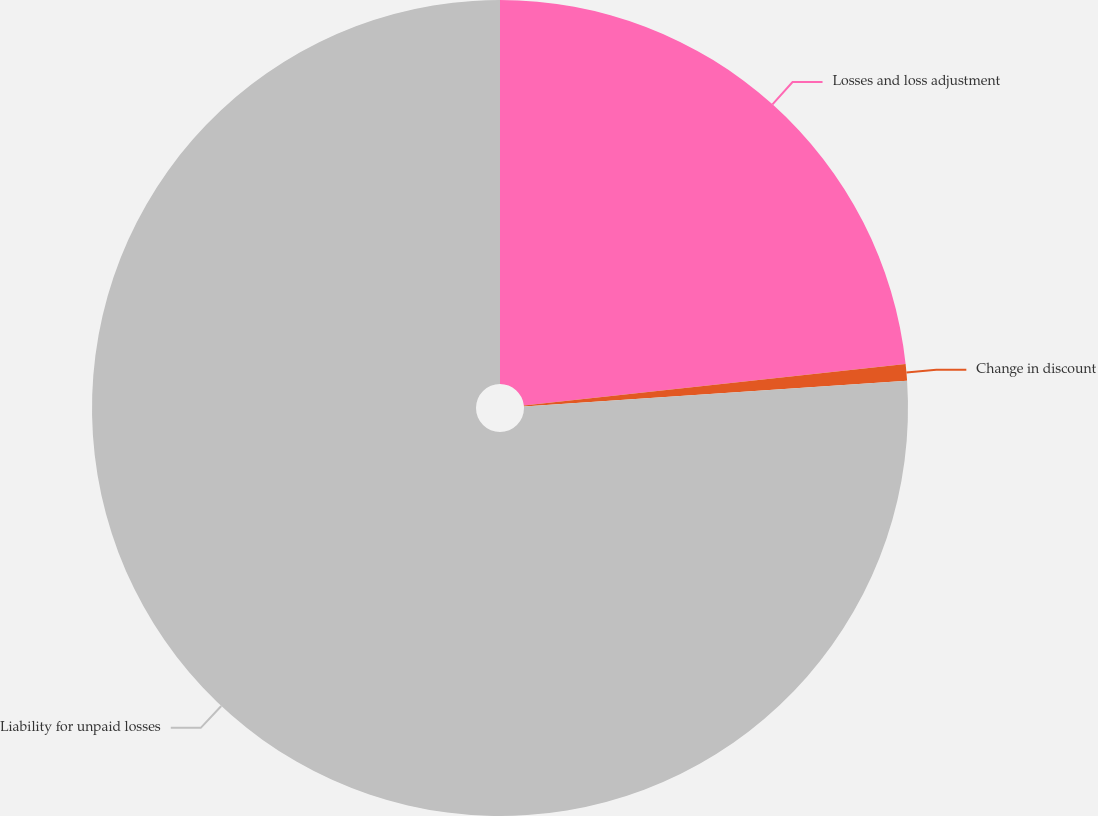Convert chart. <chart><loc_0><loc_0><loc_500><loc_500><pie_chart><fcel>Losses and loss adjustment<fcel>Change in discount<fcel>Liability for unpaid losses<nl><fcel>23.28%<fcel>0.66%<fcel>76.06%<nl></chart> 